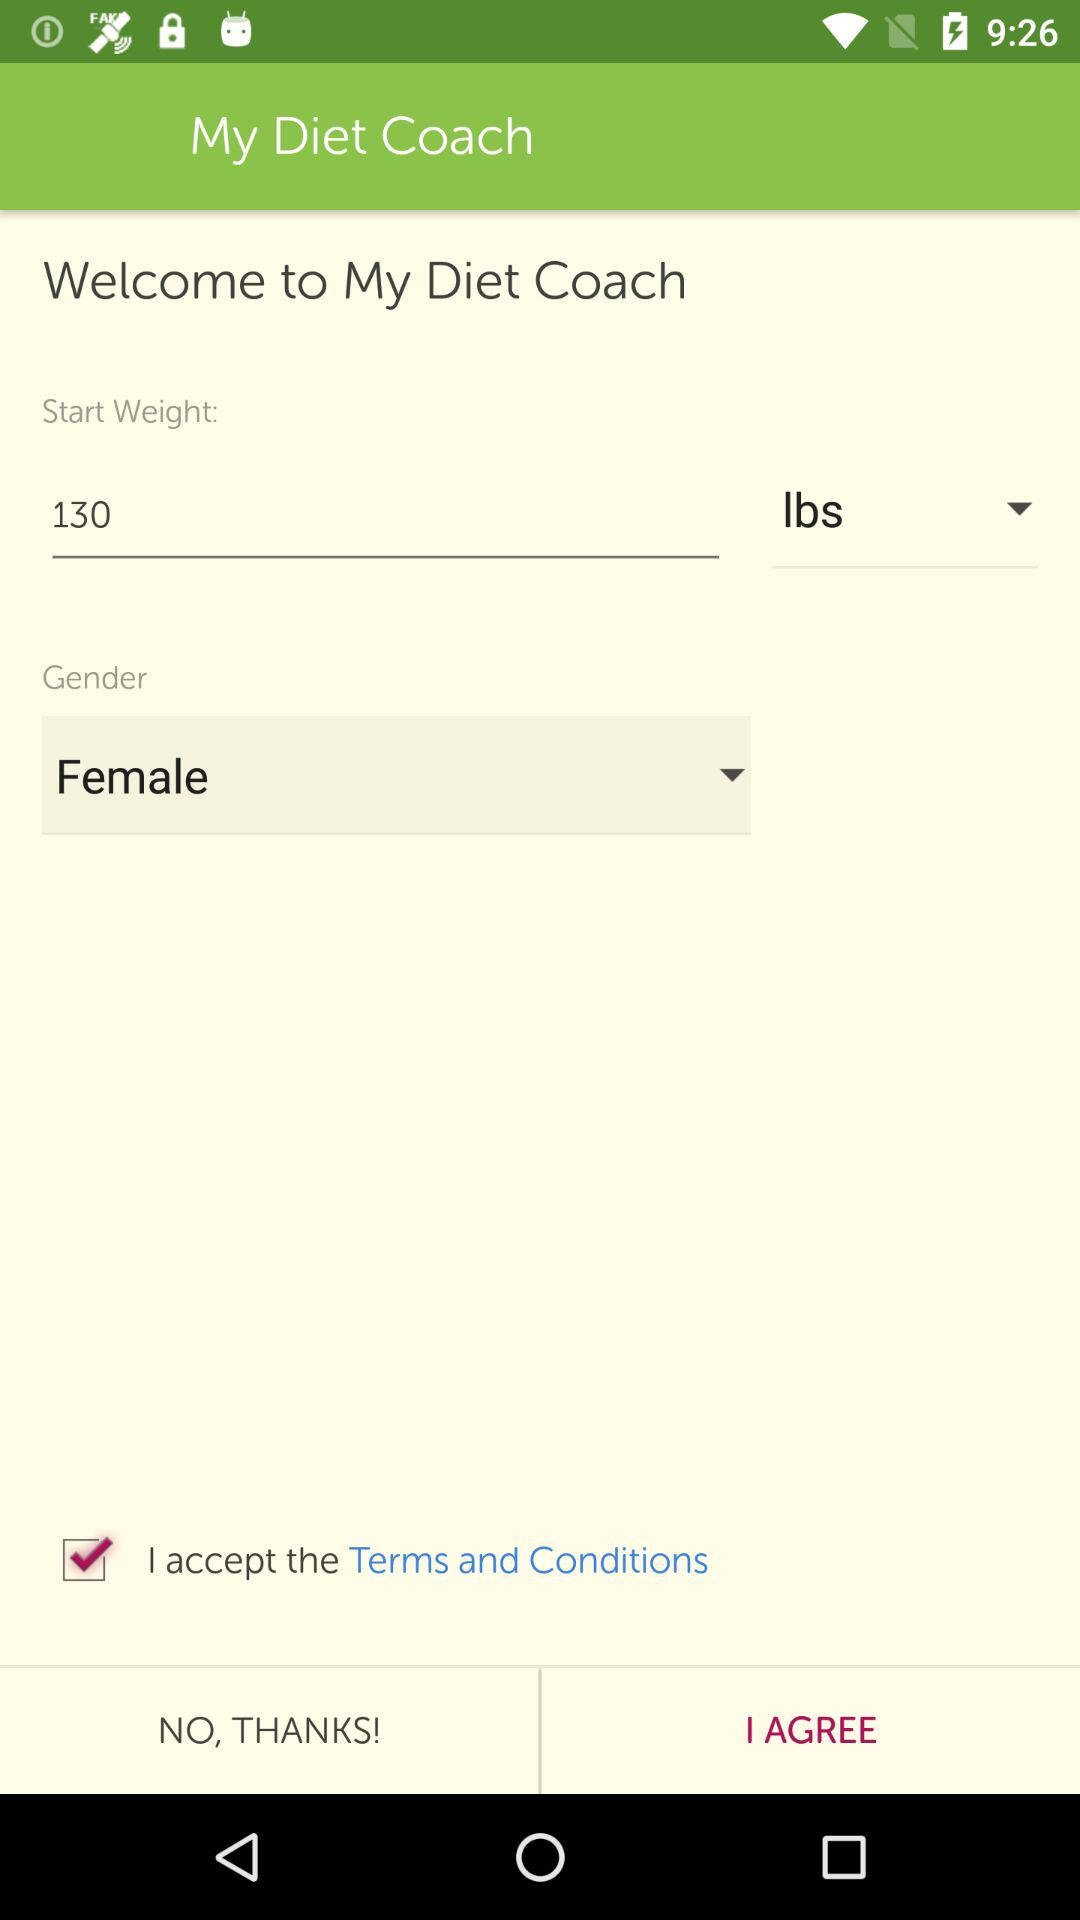What is the unit of weight? The unit of weight is lbs. 